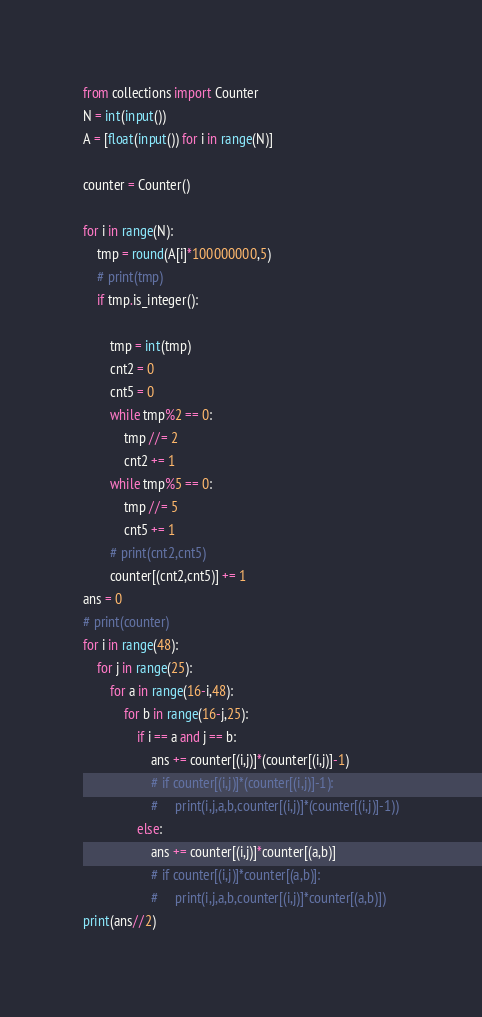<code> <loc_0><loc_0><loc_500><loc_500><_Python_>from collections import Counter
N = int(input())
A = [float(input()) for i in range(N)]

counter = Counter()

for i in range(N):
    tmp = round(A[i]*100000000,5)
    # print(tmp)
    if tmp.is_integer():
        
        tmp = int(tmp)
        cnt2 = 0
        cnt5 = 0
        while tmp%2 == 0:
            tmp //= 2
            cnt2 += 1
        while tmp%5 == 0:
            tmp //= 5
            cnt5 += 1
        # print(cnt2,cnt5)
        counter[(cnt2,cnt5)] += 1
ans = 0
# print(counter)
for i in range(48):
    for j in range(25):
        for a in range(16-i,48):
            for b in range(16-j,25):
                if i == a and j == b:
                    ans += counter[(i,j)]*(counter[(i,j)]-1)
                    # if counter[(i,j)]*(counter[(i,j)]-1):
                    #     print(i,j,a,b,counter[(i,j)]*(counter[(i,j)]-1))
                else:
                    ans += counter[(i,j)]*counter[(a,b)]
                    # if counter[(i,j)]*counter[(a,b)]:
                    #     print(i,j,a,b,counter[(i,j)]*counter[(a,b)])
print(ans//2)</code> 